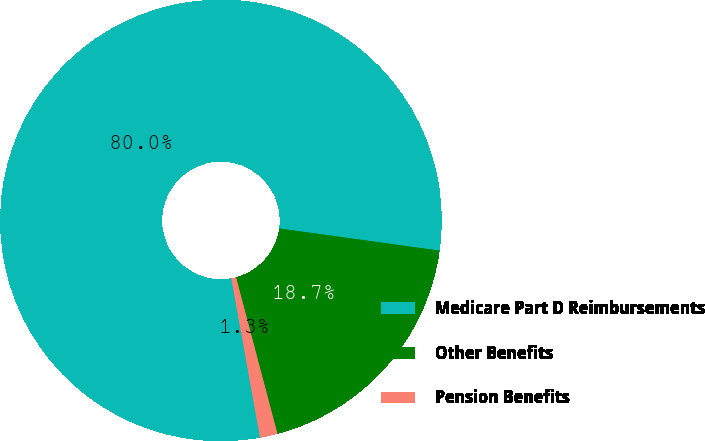Convert chart. <chart><loc_0><loc_0><loc_500><loc_500><pie_chart><fcel>Medicare Part D Reimbursements<fcel>Other Benefits<fcel>Pension Benefits<nl><fcel>80.03%<fcel>18.7%<fcel>1.28%<nl></chart> 